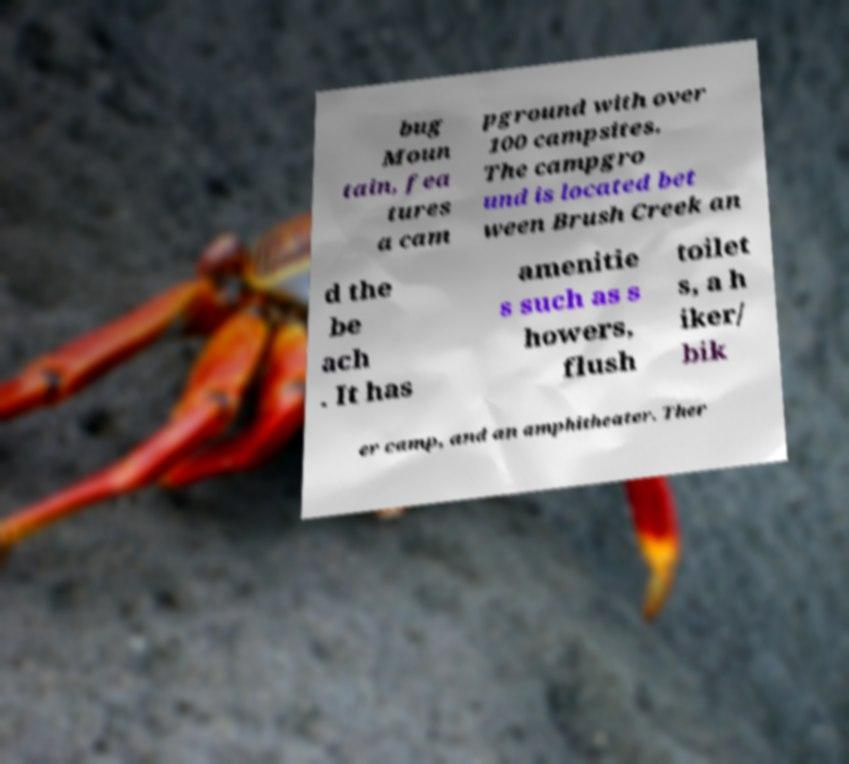For documentation purposes, I need the text within this image transcribed. Could you provide that? bug Moun tain, fea tures a cam pground with over 100 campsites. The campgro und is located bet ween Brush Creek an d the be ach . It has amenitie s such as s howers, flush toilet s, a h iker/ bik er camp, and an amphitheater. Ther 